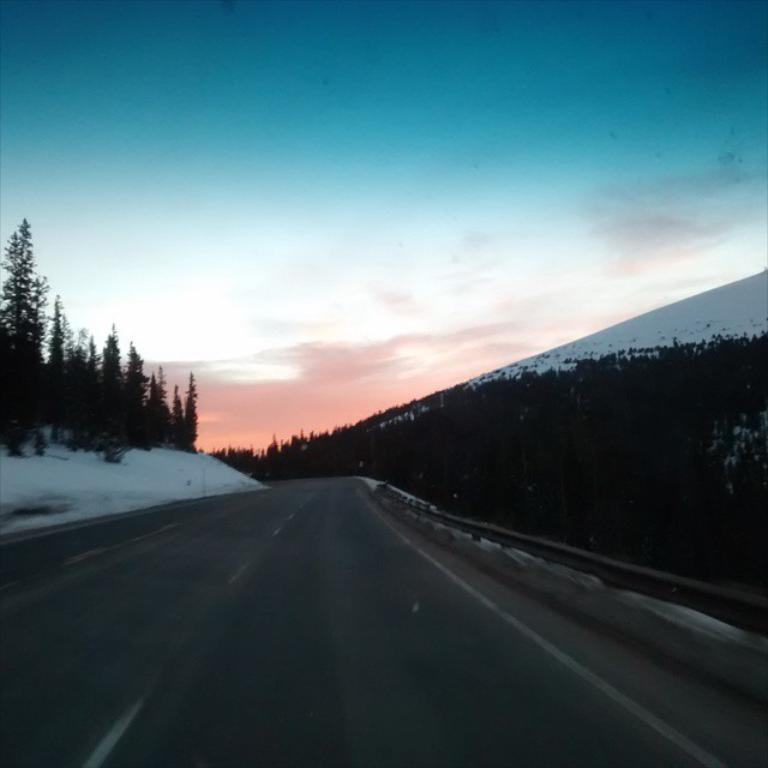What is located at the bottom of the image? There is a road at the bottom of the image. What type of weather is depicted in the image? There is snow visible in the image, indicating a snowy or wintry scene. What type of barrier is present in the image? There is fencing in the image. What type of vegetation is present in the image? There are trees in the image. What type of geographical feature is present in the image? There are hills in the image. What is visible in the sky at the top of the image? There are clouds in the sky at the top of the image. How many babies are playing with scissors in the image? There are no babies or scissors present in the image. What type of government is depicted in the image? The image does not depict any form of government or political system. 